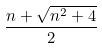<formula> <loc_0><loc_0><loc_500><loc_500>\frac { n + \sqrt { n ^ { 2 } + 4 } } { 2 }</formula> 